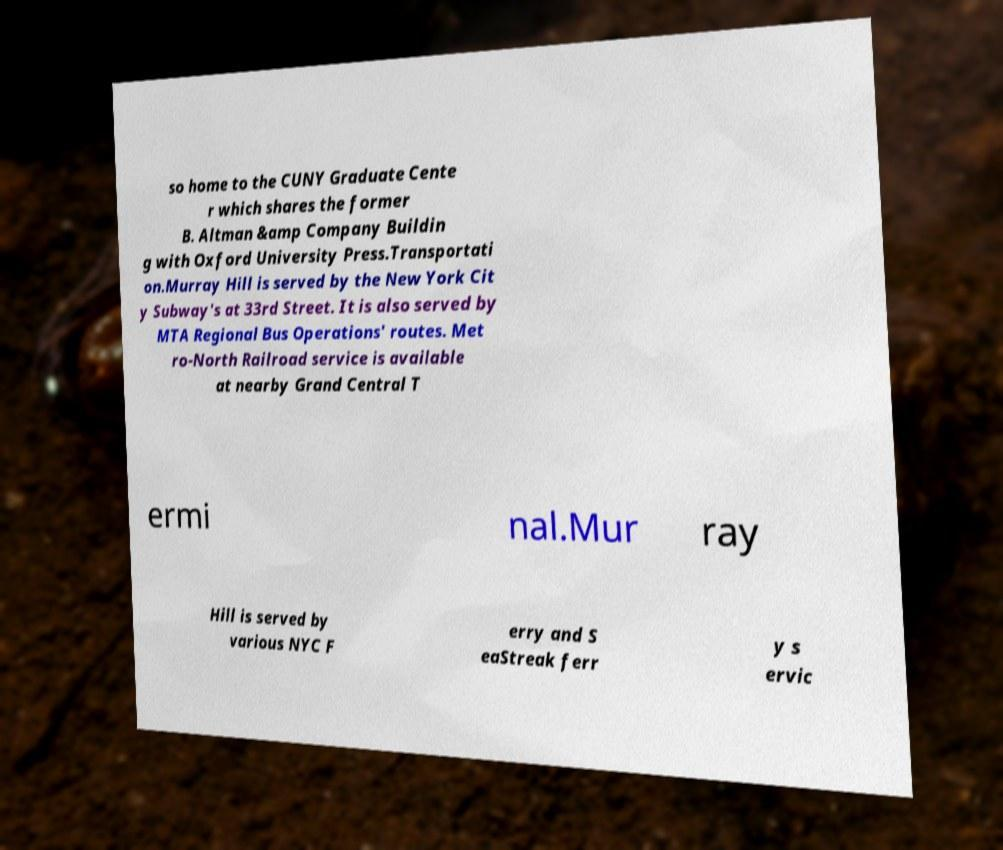I need the written content from this picture converted into text. Can you do that? so home to the CUNY Graduate Cente r which shares the former B. Altman &amp Company Buildin g with Oxford University Press.Transportati on.Murray Hill is served by the New York Cit y Subway's at 33rd Street. It is also served by MTA Regional Bus Operations' routes. Met ro-North Railroad service is available at nearby Grand Central T ermi nal.Mur ray Hill is served by various NYC F erry and S eaStreak ferr y s ervic 